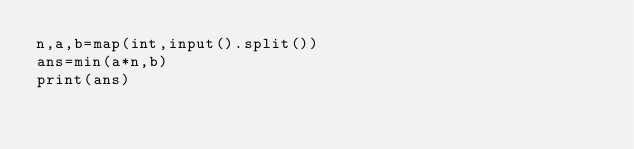Convert code to text. <code><loc_0><loc_0><loc_500><loc_500><_Python_>n,a,b=map(int,input().split())
ans=min(a*n,b)
print(ans)</code> 